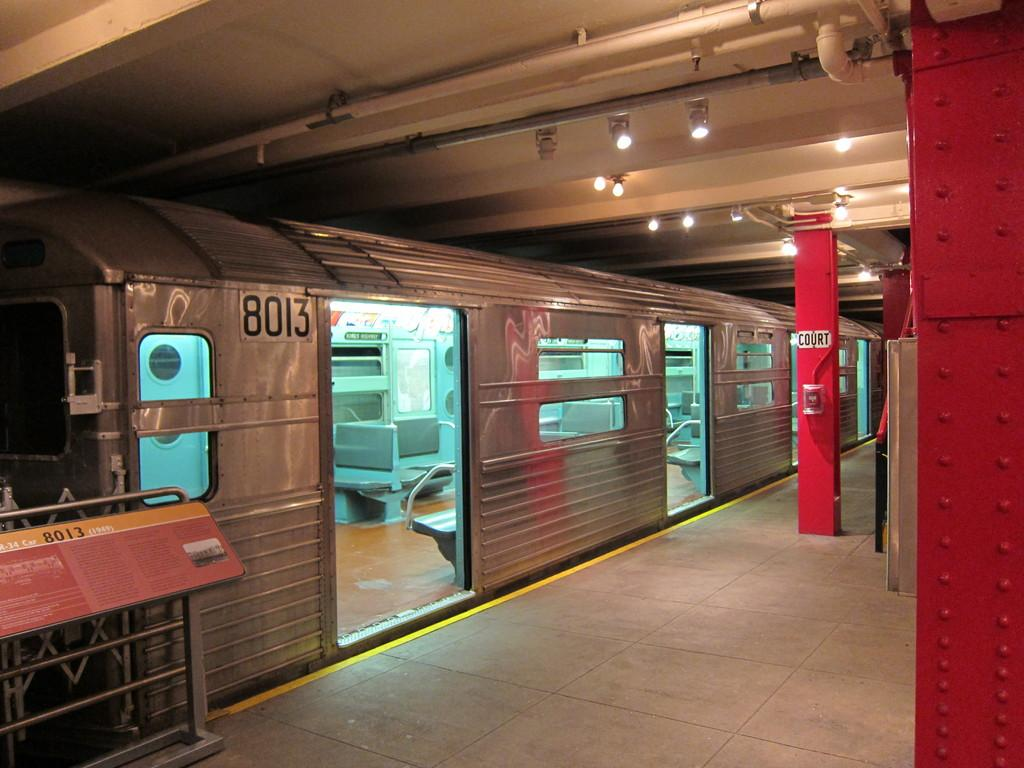What type of transportation can be seen in the image? There is a subway in the image. What is located beside the platform? There is a train beside the platform. Can you describe any specific features of the platform? There is a red color pillar on the platform. What type of calculator is being used by the person on the platform? There is no calculator visible in the image. What time is it in the image? The image does not provide any information about the time. 